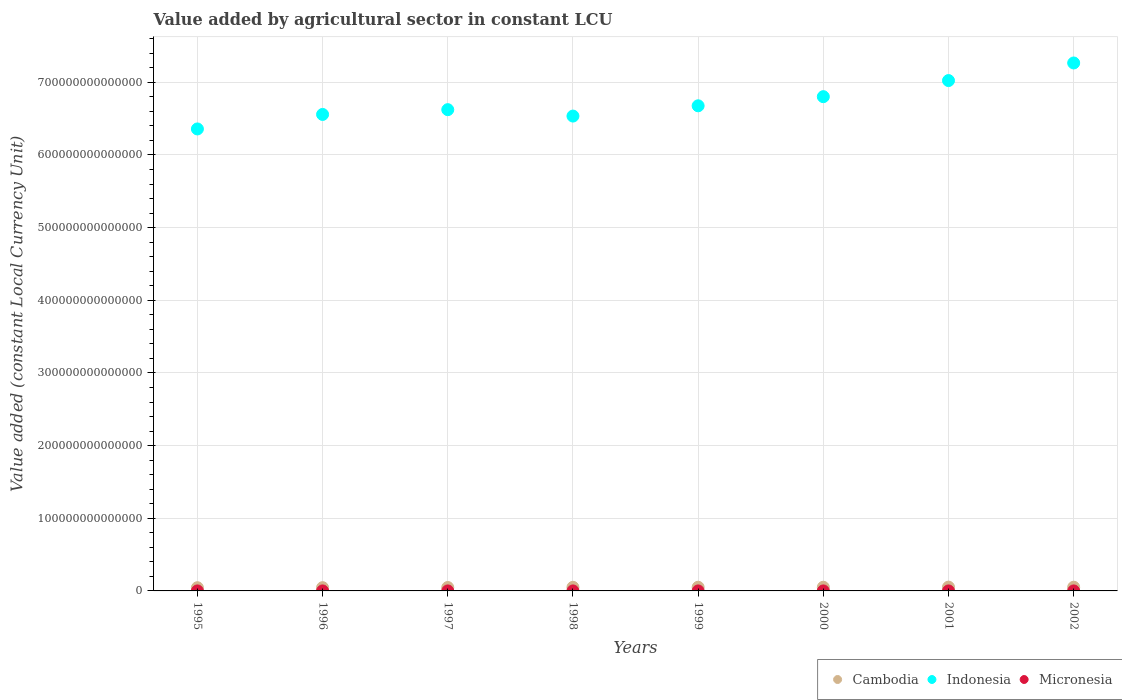How many different coloured dotlines are there?
Your answer should be very brief. 3. What is the value added by agricultural sector in Indonesia in 1995?
Offer a terse response. 6.36e+14. Across all years, what is the maximum value added by agricultural sector in Indonesia?
Your response must be concise. 7.27e+14. Across all years, what is the minimum value added by agricultural sector in Cambodia?
Offer a terse response. 4.42e+12. What is the total value added by agricultural sector in Micronesia in the graph?
Offer a terse response. 4.39e+08. What is the difference between the value added by agricultural sector in Cambodia in 1996 and that in 2000?
Your answer should be compact. -5.79e+11. What is the difference between the value added by agricultural sector in Indonesia in 1995 and the value added by agricultural sector in Cambodia in 2001?
Provide a succinct answer. 6.31e+14. What is the average value added by agricultural sector in Cambodia per year?
Your response must be concise. 4.88e+12. In the year 1998, what is the difference between the value added by agricultural sector in Cambodia and value added by agricultural sector in Indonesia?
Your answer should be very brief. -6.49e+14. In how many years, is the value added by agricultural sector in Cambodia greater than 80000000000000 LCU?
Give a very brief answer. 0. What is the ratio of the value added by agricultural sector in Indonesia in 1997 to that in 2001?
Make the answer very short. 0.94. Is the value added by agricultural sector in Micronesia in 1997 less than that in 2000?
Offer a terse response. Yes. What is the difference between the highest and the second highest value added by agricultural sector in Micronesia?
Ensure brevity in your answer.  5.61e+05. What is the difference between the highest and the lowest value added by agricultural sector in Micronesia?
Give a very brief answer. 7.32e+06. In how many years, is the value added by agricultural sector in Micronesia greater than the average value added by agricultural sector in Micronesia taken over all years?
Make the answer very short. 4. Is the sum of the value added by agricultural sector in Micronesia in 1996 and 1999 greater than the maximum value added by agricultural sector in Indonesia across all years?
Your response must be concise. No. Is it the case that in every year, the sum of the value added by agricultural sector in Indonesia and value added by agricultural sector in Cambodia  is greater than the value added by agricultural sector in Micronesia?
Your response must be concise. Yes. Is the value added by agricultural sector in Indonesia strictly less than the value added by agricultural sector in Micronesia over the years?
Your answer should be compact. No. How many dotlines are there?
Make the answer very short. 3. How many years are there in the graph?
Your response must be concise. 8. What is the difference between two consecutive major ticks on the Y-axis?
Your answer should be very brief. 1.00e+14. Are the values on the major ticks of Y-axis written in scientific E-notation?
Your response must be concise. No. Does the graph contain grids?
Make the answer very short. Yes. How are the legend labels stacked?
Offer a very short reply. Horizontal. What is the title of the graph?
Provide a succinct answer. Value added by agricultural sector in constant LCU. What is the label or title of the X-axis?
Offer a very short reply. Years. What is the label or title of the Y-axis?
Your response must be concise. Value added (constant Local Currency Unit). What is the Value added (constant Local Currency Unit) in Cambodia in 1995?
Provide a succinct answer. 4.42e+12. What is the Value added (constant Local Currency Unit) of Indonesia in 1995?
Ensure brevity in your answer.  6.36e+14. What is the Value added (constant Local Currency Unit) in Micronesia in 1995?
Provide a short and direct response. 5.68e+07. What is the Value added (constant Local Currency Unit) of Cambodia in 1996?
Your response must be concise. 4.48e+12. What is the Value added (constant Local Currency Unit) of Indonesia in 1996?
Provide a succinct answer. 6.56e+14. What is the Value added (constant Local Currency Unit) in Micronesia in 1996?
Provide a succinct answer. 5.46e+07. What is the Value added (constant Local Currency Unit) in Cambodia in 1997?
Your answer should be very brief. 4.72e+12. What is the Value added (constant Local Currency Unit) in Indonesia in 1997?
Ensure brevity in your answer.  6.62e+14. What is the Value added (constant Local Currency Unit) of Micronesia in 1997?
Your answer should be very brief. 5.00e+07. What is the Value added (constant Local Currency Unit) of Cambodia in 1998?
Offer a very short reply. 4.97e+12. What is the Value added (constant Local Currency Unit) in Indonesia in 1998?
Offer a very short reply. 6.54e+14. What is the Value added (constant Local Currency Unit) in Micronesia in 1998?
Ensure brevity in your answer.  5.73e+07. What is the Value added (constant Local Currency Unit) in Cambodia in 1999?
Ensure brevity in your answer.  5.08e+12. What is the Value added (constant Local Currency Unit) of Indonesia in 1999?
Make the answer very short. 6.68e+14. What is the Value added (constant Local Currency Unit) of Micronesia in 1999?
Offer a terse response. 5.30e+07. What is the Value added (constant Local Currency Unit) of Cambodia in 2000?
Offer a very short reply. 5.06e+12. What is the Value added (constant Local Currency Unit) in Indonesia in 2000?
Provide a short and direct response. 6.80e+14. What is the Value added (constant Local Currency Unit) of Micronesia in 2000?
Keep it short and to the point. 5.66e+07. What is the Value added (constant Local Currency Unit) in Cambodia in 2001?
Offer a terse response. 5.24e+12. What is the Value added (constant Local Currency Unit) in Indonesia in 2001?
Give a very brief answer. 7.02e+14. What is the Value added (constant Local Currency Unit) of Micronesia in 2001?
Offer a very short reply. 5.47e+07. What is the Value added (constant Local Currency Unit) of Cambodia in 2002?
Make the answer very short. 5.11e+12. What is the Value added (constant Local Currency Unit) of Indonesia in 2002?
Offer a very short reply. 7.27e+14. What is the Value added (constant Local Currency Unit) in Micronesia in 2002?
Provide a short and direct response. 5.57e+07. Across all years, what is the maximum Value added (constant Local Currency Unit) of Cambodia?
Offer a terse response. 5.24e+12. Across all years, what is the maximum Value added (constant Local Currency Unit) of Indonesia?
Your answer should be compact. 7.27e+14. Across all years, what is the maximum Value added (constant Local Currency Unit) of Micronesia?
Your response must be concise. 5.73e+07. Across all years, what is the minimum Value added (constant Local Currency Unit) of Cambodia?
Provide a succinct answer. 4.42e+12. Across all years, what is the minimum Value added (constant Local Currency Unit) of Indonesia?
Keep it short and to the point. 6.36e+14. Across all years, what is the minimum Value added (constant Local Currency Unit) of Micronesia?
Provide a short and direct response. 5.00e+07. What is the total Value added (constant Local Currency Unit) in Cambodia in the graph?
Keep it short and to the point. 3.91e+13. What is the total Value added (constant Local Currency Unit) in Indonesia in the graph?
Ensure brevity in your answer.  5.38e+15. What is the total Value added (constant Local Currency Unit) in Micronesia in the graph?
Ensure brevity in your answer.  4.39e+08. What is the difference between the Value added (constant Local Currency Unit) of Cambodia in 1995 and that in 1996?
Ensure brevity in your answer.  -5.79e+1. What is the difference between the Value added (constant Local Currency Unit) in Indonesia in 1995 and that in 1996?
Your response must be concise. -2.00e+13. What is the difference between the Value added (constant Local Currency Unit) in Micronesia in 1995 and that in 1996?
Offer a terse response. 2.14e+06. What is the difference between the Value added (constant Local Currency Unit) in Cambodia in 1995 and that in 1997?
Keep it short and to the point. -3.01e+11. What is the difference between the Value added (constant Local Currency Unit) of Indonesia in 1995 and that in 1997?
Provide a succinct answer. -2.65e+13. What is the difference between the Value added (constant Local Currency Unit) of Micronesia in 1995 and that in 1997?
Keep it short and to the point. 6.76e+06. What is the difference between the Value added (constant Local Currency Unit) of Cambodia in 1995 and that in 1998?
Your response must be concise. -5.45e+11. What is the difference between the Value added (constant Local Currency Unit) in Indonesia in 1995 and that in 1998?
Provide a short and direct response. -1.77e+13. What is the difference between the Value added (constant Local Currency Unit) of Micronesia in 1995 and that in 1998?
Your answer should be very brief. -5.61e+05. What is the difference between the Value added (constant Local Currency Unit) in Cambodia in 1995 and that in 1999?
Your answer should be compact. -6.56e+11. What is the difference between the Value added (constant Local Currency Unit) in Indonesia in 1995 and that in 1999?
Provide a short and direct response. -3.19e+13. What is the difference between the Value added (constant Local Currency Unit) in Micronesia in 1995 and that in 1999?
Offer a very short reply. 3.80e+06. What is the difference between the Value added (constant Local Currency Unit) in Cambodia in 1995 and that in 2000?
Your response must be concise. -6.37e+11. What is the difference between the Value added (constant Local Currency Unit) of Indonesia in 1995 and that in 2000?
Give a very brief answer. -4.44e+13. What is the difference between the Value added (constant Local Currency Unit) in Micronesia in 1995 and that in 2000?
Your answer should be very brief. 2.23e+05. What is the difference between the Value added (constant Local Currency Unit) of Cambodia in 1995 and that in 2001?
Keep it short and to the point. -8.17e+11. What is the difference between the Value added (constant Local Currency Unit) of Indonesia in 1995 and that in 2001?
Ensure brevity in your answer.  -6.66e+13. What is the difference between the Value added (constant Local Currency Unit) in Micronesia in 1995 and that in 2001?
Provide a short and direct response. 2.12e+06. What is the difference between the Value added (constant Local Currency Unit) of Cambodia in 1995 and that in 2002?
Make the answer very short. -6.86e+11. What is the difference between the Value added (constant Local Currency Unit) in Indonesia in 1995 and that in 2002?
Provide a succinct answer. -9.08e+13. What is the difference between the Value added (constant Local Currency Unit) in Micronesia in 1995 and that in 2002?
Your answer should be very brief. 1.03e+06. What is the difference between the Value added (constant Local Currency Unit) in Cambodia in 1996 and that in 1997?
Ensure brevity in your answer.  -2.43e+11. What is the difference between the Value added (constant Local Currency Unit) in Indonesia in 1996 and that in 1997?
Offer a terse response. -6.58e+12. What is the difference between the Value added (constant Local Currency Unit) of Micronesia in 1996 and that in 1997?
Your answer should be compact. 4.62e+06. What is the difference between the Value added (constant Local Currency Unit) in Cambodia in 1996 and that in 1998?
Offer a very short reply. -4.87e+11. What is the difference between the Value added (constant Local Currency Unit) of Indonesia in 1996 and that in 1998?
Give a very brief answer. 2.24e+12. What is the difference between the Value added (constant Local Currency Unit) in Micronesia in 1996 and that in 1998?
Provide a short and direct response. -2.70e+06. What is the difference between the Value added (constant Local Currency Unit) of Cambodia in 1996 and that in 1999?
Provide a short and direct response. -5.98e+11. What is the difference between the Value added (constant Local Currency Unit) in Indonesia in 1996 and that in 1999?
Offer a terse response. -1.19e+13. What is the difference between the Value added (constant Local Currency Unit) in Micronesia in 1996 and that in 1999?
Ensure brevity in your answer.  1.66e+06. What is the difference between the Value added (constant Local Currency Unit) of Cambodia in 1996 and that in 2000?
Your response must be concise. -5.79e+11. What is the difference between the Value added (constant Local Currency Unit) in Indonesia in 1996 and that in 2000?
Your answer should be very brief. -2.45e+13. What is the difference between the Value added (constant Local Currency Unit) in Micronesia in 1996 and that in 2000?
Offer a terse response. -1.92e+06. What is the difference between the Value added (constant Local Currency Unit) in Cambodia in 1996 and that in 2001?
Give a very brief answer. -7.59e+11. What is the difference between the Value added (constant Local Currency Unit) of Indonesia in 1996 and that in 2001?
Your response must be concise. -4.66e+13. What is the difference between the Value added (constant Local Currency Unit) of Micronesia in 1996 and that in 2001?
Give a very brief answer. -1.49e+04. What is the difference between the Value added (constant Local Currency Unit) of Cambodia in 1996 and that in 2002?
Give a very brief answer. -6.29e+11. What is the difference between the Value added (constant Local Currency Unit) in Indonesia in 1996 and that in 2002?
Offer a very short reply. -7.08e+13. What is the difference between the Value added (constant Local Currency Unit) of Micronesia in 1996 and that in 2002?
Provide a succinct answer. -1.11e+06. What is the difference between the Value added (constant Local Currency Unit) in Cambodia in 1997 and that in 1998?
Offer a terse response. -2.45e+11. What is the difference between the Value added (constant Local Currency Unit) in Indonesia in 1997 and that in 1998?
Provide a succinct answer. 8.82e+12. What is the difference between the Value added (constant Local Currency Unit) in Micronesia in 1997 and that in 1998?
Provide a succinct answer. -7.32e+06. What is the difference between the Value added (constant Local Currency Unit) in Cambodia in 1997 and that in 1999?
Provide a succinct answer. -3.56e+11. What is the difference between the Value added (constant Local Currency Unit) in Indonesia in 1997 and that in 1999?
Your response must be concise. -5.32e+12. What is the difference between the Value added (constant Local Currency Unit) of Micronesia in 1997 and that in 1999?
Offer a terse response. -2.96e+06. What is the difference between the Value added (constant Local Currency Unit) of Cambodia in 1997 and that in 2000?
Ensure brevity in your answer.  -3.36e+11. What is the difference between the Value added (constant Local Currency Unit) in Indonesia in 1997 and that in 2000?
Offer a terse response. -1.79e+13. What is the difference between the Value added (constant Local Currency Unit) of Micronesia in 1997 and that in 2000?
Your response must be concise. -6.54e+06. What is the difference between the Value added (constant Local Currency Unit) of Cambodia in 1997 and that in 2001?
Your response must be concise. -5.16e+11. What is the difference between the Value added (constant Local Currency Unit) of Indonesia in 1997 and that in 2001?
Your answer should be compact. -4.00e+13. What is the difference between the Value added (constant Local Currency Unit) in Micronesia in 1997 and that in 2001?
Your answer should be compact. -4.64e+06. What is the difference between the Value added (constant Local Currency Unit) in Cambodia in 1997 and that in 2002?
Give a very brief answer. -3.86e+11. What is the difference between the Value added (constant Local Currency Unit) of Indonesia in 1997 and that in 2002?
Offer a terse response. -6.43e+13. What is the difference between the Value added (constant Local Currency Unit) of Micronesia in 1997 and that in 2002?
Offer a very short reply. -5.73e+06. What is the difference between the Value added (constant Local Currency Unit) of Cambodia in 1998 and that in 1999?
Your answer should be compact. -1.11e+11. What is the difference between the Value added (constant Local Currency Unit) in Indonesia in 1998 and that in 1999?
Give a very brief answer. -1.41e+13. What is the difference between the Value added (constant Local Currency Unit) in Micronesia in 1998 and that in 1999?
Give a very brief answer. 4.36e+06. What is the difference between the Value added (constant Local Currency Unit) in Cambodia in 1998 and that in 2000?
Give a very brief answer. -9.16e+1. What is the difference between the Value added (constant Local Currency Unit) of Indonesia in 1998 and that in 2000?
Your answer should be compact. -2.67e+13. What is the difference between the Value added (constant Local Currency Unit) in Micronesia in 1998 and that in 2000?
Give a very brief answer. 7.85e+05. What is the difference between the Value added (constant Local Currency Unit) in Cambodia in 1998 and that in 2001?
Your response must be concise. -2.72e+11. What is the difference between the Value added (constant Local Currency Unit) of Indonesia in 1998 and that in 2001?
Offer a very short reply. -4.89e+13. What is the difference between the Value added (constant Local Currency Unit) in Micronesia in 1998 and that in 2001?
Give a very brief answer. 2.69e+06. What is the difference between the Value added (constant Local Currency Unit) of Cambodia in 1998 and that in 2002?
Your answer should be very brief. -1.41e+11. What is the difference between the Value added (constant Local Currency Unit) of Indonesia in 1998 and that in 2002?
Offer a very short reply. -7.31e+13. What is the difference between the Value added (constant Local Currency Unit) in Micronesia in 1998 and that in 2002?
Your response must be concise. 1.59e+06. What is the difference between the Value added (constant Local Currency Unit) of Cambodia in 1999 and that in 2000?
Your answer should be very brief. 1.93e+1. What is the difference between the Value added (constant Local Currency Unit) in Indonesia in 1999 and that in 2000?
Make the answer very short. -1.26e+13. What is the difference between the Value added (constant Local Currency Unit) in Micronesia in 1999 and that in 2000?
Make the answer very short. -3.58e+06. What is the difference between the Value added (constant Local Currency Unit) of Cambodia in 1999 and that in 2001?
Your answer should be compact. -1.61e+11. What is the difference between the Value added (constant Local Currency Unit) in Indonesia in 1999 and that in 2001?
Provide a short and direct response. -3.47e+13. What is the difference between the Value added (constant Local Currency Unit) of Micronesia in 1999 and that in 2001?
Provide a short and direct response. -1.68e+06. What is the difference between the Value added (constant Local Currency Unit) in Cambodia in 1999 and that in 2002?
Provide a succinct answer. -3.04e+1. What is the difference between the Value added (constant Local Currency Unit) in Indonesia in 1999 and that in 2002?
Your answer should be very brief. -5.89e+13. What is the difference between the Value added (constant Local Currency Unit) in Micronesia in 1999 and that in 2002?
Your response must be concise. -2.77e+06. What is the difference between the Value added (constant Local Currency Unit) in Cambodia in 2000 and that in 2001?
Your answer should be compact. -1.80e+11. What is the difference between the Value added (constant Local Currency Unit) of Indonesia in 2000 and that in 2001?
Offer a very short reply. -2.21e+13. What is the difference between the Value added (constant Local Currency Unit) in Micronesia in 2000 and that in 2001?
Make the answer very short. 1.90e+06. What is the difference between the Value added (constant Local Currency Unit) in Cambodia in 2000 and that in 2002?
Your answer should be very brief. -4.97e+1. What is the difference between the Value added (constant Local Currency Unit) of Indonesia in 2000 and that in 2002?
Ensure brevity in your answer.  -4.64e+13. What is the difference between the Value added (constant Local Currency Unit) in Micronesia in 2000 and that in 2002?
Provide a succinct answer. 8.08e+05. What is the difference between the Value added (constant Local Currency Unit) of Cambodia in 2001 and that in 2002?
Your response must be concise. 1.30e+11. What is the difference between the Value added (constant Local Currency Unit) of Indonesia in 2001 and that in 2002?
Keep it short and to the point. -2.42e+13. What is the difference between the Value added (constant Local Currency Unit) of Micronesia in 2001 and that in 2002?
Offer a terse response. -1.09e+06. What is the difference between the Value added (constant Local Currency Unit) of Cambodia in 1995 and the Value added (constant Local Currency Unit) of Indonesia in 1996?
Provide a short and direct response. -6.51e+14. What is the difference between the Value added (constant Local Currency Unit) of Cambodia in 1995 and the Value added (constant Local Currency Unit) of Micronesia in 1996?
Provide a short and direct response. 4.42e+12. What is the difference between the Value added (constant Local Currency Unit) in Indonesia in 1995 and the Value added (constant Local Currency Unit) in Micronesia in 1996?
Offer a very short reply. 6.36e+14. What is the difference between the Value added (constant Local Currency Unit) in Cambodia in 1995 and the Value added (constant Local Currency Unit) in Indonesia in 1997?
Your answer should be compact. -6.58e+14. What is the difference between the Value added (constant Local Currency Unit) of Cambodia in 1995 and the Value added (constant Local Currency Unit) of Micronesia in 1997?
Keep it short and to the point. 4.42e+12. What is the difference between the Value added (constant Local Currency Unit) in Indonesia in 1995 and the Value added (constant Local Currency Unit) in Micronesia in 1997?
Make the answer very short. 6.36e+14. What is the difference between the Value added (constant Local Currency Unit) in Cambodia in 1995 and the Value added (constant Local Currency Unit) in Indonesia in 1998?
Provide a succinct answer. -6.49e+14. What is the difference between the Value added (constant Local Currency Unit) in Cambodia in 1995 and the Value added (constant Local Currency Unit) in Micronesia in 1998?
Offer a very short reply. 4.42e+12. What is the difference between the Value added (constant Local Currency Unit) in Indonesia in 1995 and the Value added (constant Local Currency Unit) in Micronesia in 1998?
Give a very brief answer. 6.36e+14. What is the difference between the Value added (constant Local Currency Unit) in Cambodia in 1995 and the Value added (constant Local Currency Unit) in Indonesia in 1999?
Your response must be concise. -6.63e+14. What is the difference between the Value added (constant Local Currency Unit) of Cambodia in 1995 and the Value added (constant Local Currency Unit) of Micronesia in 1999?
Keep it short and to the point. 4.42e+12. What is the difference between the Value added (constant Local Currency Unit) of Indonesia in 1995 and the Value added (constant Local Currency Unit) of Micronesia in 1999?
Offer a very short reply. 6.36e+14. What is the difference between the Value added (constant Local Currency Unit) of Cambodia in 1995 and the Value added (constant Local Currency Unit) of Indonesia in 2000?
Provide a short and direct response. -6.76e+14. What is the difference between the Value added (constant Local Currency Unit) in Cambodia in 1995 and the Value added (constant Local Currency Unit) in Micronesia in 2000?
Provide a short and direct response. 4.42e+12. What is the difference between the Value added (constant Local Currency Unit) in Indonesia in 1995 and the Value added (constant Local Currency Unit) in Micronesia in 2000?
Give a very brief answer. 6.36e+14. What is the difference between the Value added (constant Local Currency Unit) in Cambodia in 1995 and the Value added (constant Local Currency Unit) in Indonesia in 2001?
Give a very brief answer. -6.98e+14. What is the difference between the Value added (constant Local Currency Unit) of Cambodia in 1995 and the Value added (constant Local Currency Unit) of Micronesia in 2001?
Offer a very short reply. 4.42e+12. What is the difference between the Value added (constant Local Currency Unit) of Indonesia in 1995 and the Value added (constant Local Currency Unit) of Micronesia in 2001?
Your answer should be compact. 6.36e+14. What is the difference between the Value added (constant Local Currency Unit) of Cambodia in 1995 and the Value added (constant Local Currency Unit) of Indonesia in 2002?
Give a very brief answer. -7.22e+14. What is the difference between the Value added (constant Local Currency Unit) of Cambodia in 1995 and the Value added (constant Local Currency Unit) of Micronesia in 2002?
Your answer should be compact. 4.42e+12. What is the difference between the Value added (constant Local Currency Unit) in Indonesia in 1995 and the Value added (constant Local Currency Unit) in Micronesia in 2002?
Offer a very short reply. 6.36e+14. What is the difference between the Value added (constant Local Currency Unit) in Cambodia in 1996 and the Value added (constant Local Currency Unit) in Indonesia in 1997?
Your answer should be very brief. -6.58e+14. What is the difference between the Value added (constant Local Currency Unit) in Cambodia in 1996 and the Value added (constant Local Currency Unit) in Micronesia in 1997?
Make the answer very short. 4.48e+12. What is the difference between the Value added (constant Local Currency Unit) of Indonesia in 1996 and the Value added (constant Local Currency Unit) of Micronesia in 1997?
Make the answer very short. 6.56e+14. What is the difference between the Value added (constant Local Currency Unit) of Cambodia in 1996 and the Value added (constant Local Currency Unit) of Indonesia in 1998?
Provide a succinct answer. -6.49e+14. What is the difference between the Value added (constant Local Currency Unit) of Cambodia in 1996 and the Value added (constant Local Currency Unit) of Micronesia in 1998?
Your response must be concise. 4.48e+12. What is the difference between the Value added (constant Local Currency Unit) in Indonesia in 1996 and the Value added (constant Local Currency Unit) in Micronesia in 1998?
Offer a very short reply. 6.56e+14. What is the difference between the Value added (constant Local Currency Unit) in Cambodia in 1996 and the Value added (constant Local Currency Unit) in Indonesia in 1999?
Keep it short and to the point. -6.63e+14. What is the difference between the Value added (constant Local Currency Unit) in Cambodia in 1996 and the Value added (constant Local Currency Unit) in Micronesia in 1999?
Keep it short and to the point. 4.48e+12. What is the difference between the Value added (constant Local Currency Unit) of Indonesia in 1996 and the Value added (constant Local Currency Unit) of Micronesia in 1999?
Give a very brief answer. 6.56e+14. What is the difference between the Value added (constant Local Currency Unit) of Cambodia in 1996 and the Value added (constant Local Currency Unit) of Indonesia in 2000?
Give a very brief answer. -6.76e+14. What is the difference between the Value added (constant Local Currency Unit) of Cambodia in 1996 and the Value added (constant Local Currency Unit) of Micronesia in 2000?
Ensure brevity in your answer.  4.48e+12. What is the difference between the Value added (constant Local Currency Unit) in Indonesia in 1996 and the Value added (constant Local Currency Unit) in Micronesia in 2000?
Give a very brief answer. 6.56e+14. What is the difference between the Value added (constant Local Currency Unit) of Cambodia in 1996 and the Value added (constant Local Currency Unit) of Indonesia in 2001?
Provide a succinct answer. -6.98e+14. What is the difference between the Value added (constant Local Currency Unit) of Cambodia in 1996 and the Value added (constant Local Currency Unit) of Micronesia in 2001?
Provide a short and direct response. 4.48e+12. What is the difference between the Value added (constant Local Currency Unit) in Indonesia in 1996 and the Value added (constant Local Currency Unit) in Micronesia in 2001?
Give a very brief answer. 6.56e+14. What is the difference between the Value added (constant Local Currency Unit) in Cambodia in 1996 and the Value added (constant Local Currency Unit) in Indonesia in 2002?
Give a very brief answer. -7.22e+14. What is the difference between the Value added (constant Local Currency Unit) in Cambodia in 1996 and the Value added (constant Local Currency Unit) in Micronesia in 2002?
Your answer should be very brief. 4.48e+12. What is the difference between the Value added (constant Local Currency Unit) in Indonesia in 1996 and the Value added (constant Local Currency Unit) in Micronesia in 2002?
Give a very brief answer. 6.56e+14. What is the difference between the Value added (constant Local Currency Unit) of Cambodia in 1997 and the Value added (constant Local Currency Unit) of Indonesia in 1998?
Keep it short and to the point. -6.49e+14. What is the difference between the Value added (constant Local Currency Unit) of Cambodia in 1997 and the Value added (constant Local Currency Unit) of Micronesia in 1998?
Offer a terse response. 4.72e+12. What is the difference between the Value added (constant Local Currency Unit) in Indonesia in 1997 and the Value added (constant Local Currency Unit) in Micronesia in 1998?
Your answer should be compact. 6.62e+14. What is the difference between the Value added (constant Local Currency Unit) of Cambodia in 1997 and the Value added (constant Local Currency Unit) of Indonesia in 1999?
Offer a very short reply. -6.63e+14. What is the difference between the Value added (constant Local Currency Unit) in Cambodia in 1997 and the Value added (constant Local Currency Unit) in Micronesia in 1999?
Offer a terse response. 4.72e+12. What is the difference between the Value added (constant Local Currency Unit) of Indonesia in 1997 and the Value added (constant Local Currency Unit) of Micronesia in 1999?
Your answer should be very brief. 6.62e+14. What is the difference between the Value added (constant Local Currency Unit) of Cambodia in 1997 and the Value added (constant Local Currency Unit) of Indonesia in 2000?
Your answer should be very brief. -6.76e+14. What is the difference between the Value added (constant Local Currency Unit) in Cambodia in 1997 and the Value added (constant Local Currency Unit) in Micronesia in 2000?
Provide a short and direct response. 4.72e+12. What is the difference between the Value added (constant Local Currency Unit) of Indonesia in 1997 and the Value added (constant Local Currency Unit) of Micronesia in 2000?
Offer a very short reply. 6.62e+14. What is the difference between the Value added (constant Local Currency Unit) of Cambodia in 1997 and the Value added (constant Local Currency Unit) of Indonesia in 2001?
Ensure brevity in your answer.  -6.98e+14. What is the difference between the Value added (constant Local Currency Unit) in Cambodia in 1997 and the Value added (constant Local Currency Unit) in Micronesia in 2001?
Your response must be concise. 4.72e+12. What is the difference between the Value added (constant Local Currency Unit) of Indonesia in 1997 and the Value added (constant Local Currency Unit) of Micronesia in 2001?
Your answer should be compact. 6.62e+14. What is the difference between the Value added (constant Local Currency Unit) in Cambodia in 1997 and the Value added (constant Local Currency Unit) in Indonesia in 2002?
Ensure brevity in your answer.  -7.22e+14. What is the difference between the Value added (constant Local Currency Unit) in Cambodia in 1997 and the Value added (constant Local Currency Unit) in Micronesia in 2002?
Offer a terse response. 4.72e+12. What is the difference between the Value added (constant Local Currency Unit) in Indonesia in 1997 and the Value added (constant Local Currency Unit) in Micronesia in 2002?
Your answer should be compact. 6.62e+14. What is the difference between the Value added (constant Local Currency Unit) in Cambodia in 1998 and the Value added (constant Local Currency Unit) in Indonesia in 1999?
Provide a short and direct response. -6.63e+14. What is the difference between the Value added (constant Local Currency Unit) of Cambodia in 1998 and the Value added (constant Local Currency Unit) of Micronesia in 1999?
Provide a short and direct response. 4.97e+12. What is the difference between the Value added (constant Local Currency Unit) in Indonesia in 1998 and the Value added (constant Local Currency Unit) in Micronesia in 1999?
Give a very brief answer. 6.54e+14. What is the difference between the Value added (constant Local Currency Unit) of Cambodia in 1998 and the Value added (constant Local Currency Unit) of Indonesia in 2000?
Offer a terse response. -6.75e+14. What is the difference between the Value added (constant Local Currency Unit) of Cambodia in 1998 and the Value added (constant Local Currency Unit) of Micronesia in 2000?
Provide a short and direct response. 4.97e+12. What is the difference between the Value added (constant Local Currency Unit) in Indonesia in 1998 and the Value added (constant Local Currency Unit) in Micronesia in 2000?
Your answer should be very brief. 6.54e+14. What is the difference between the Value added (constant Local Currency Unit) in Cambodia in 1998 and the Value added (constant Local Currency Unit) in Indonesia in 2001?
Make the answer very short. -6.97e+14. What is the difference between the Value added (constant Local Currency Unit) of Cambodia in 1998 and the Value added (constant Local Currency Unit) of Micronesia in 2001?
Your response must be concise. 4.97e+12. What is the difference between the Value added (constant Local Currency Unit) of Indonesia in 1998 and the Value added (constant Local Currency Unit) of Micronesia in 2001?
Your answer should be very brief. 6.54e+14. What is the difference between the Value added (constant Local Currency Unit) of Cambodia in 1998 and the Value added (constant Local Currency Unit) of Indonesia in 2002?
Your answer should be compact. -7.22e+14. What is the difference between the Value added (constant Local Currency Unit) in Cambodia in 1998 and the Value added (constant Local Currency Unit) in Micronesia in 2002?
Make the answer very short. 4.97e+12. What is the difference between the Value added (constant Local Currency Unit) of Indonesia in 1998 and the Value added (constant Local Currency Unit) of Micronesia in 2002?
Provide a short and direct response. 6.54e+14. What is the difference between the Value added (constant Local Currency Unit) in Cambodia in 1999 and the Value added (constant Local Currency Unit) in Indonesia in 2000?
Ensure brevity in your answer.  -6.75e+14. What is the difference between the Value added (constant Local Currency Unit) of Cambodia in 1999 and the Value added (constant Local Currency Unit) of Micronesia in 2000?
Your response must be concise. 5.08e+12. What is the difference between the Value added (constant Local Currency Unit) in Indonesia in 1999 and the Value added (constant Local Currency Unit) in Micronesia in 2000?
Provide a succinct answer. 6.68e+14. What is the difference between the Value added (constant Local Currency Unit) in Cambodia in 1999 and the Value added (constant Local Currency Unit) in Indonesia in 2001?
Your response must be concise. -6.97e+14. What is the difference between the Value added (constant Local Currency Unit) in Cambodia in 1999 and the Value added (constant Local Currency Unit) in Micronesia in 2001?
Offer a very short reply. 5.08e+12. What is the difference between the Value added (constant Local Currency Unit) of Indonesia in 1999 and the Value added (constant Local Currency Unit) of Micronesia in 2001?
Make the answer very short. 6.68e+14. What is the difference between the Value added (constant Local Currency Unit) in Cambodia in 1999 and the Value added (constant Local Currency Unit) in Indonesia in 2002?
Ensure brevity in your answer.  -7.22e+14. What is the difference between the Value added (constant Local Currency Unit) of Cambodia in 1999 and the Value added (constant Local Currency Unit) of Micronesia in 2002?
Provide a short and direct response. 5.08e+12. What is the difference between the Value added (constant Local Currency Unit) of Indonesia in 1999 and the Value added (constant Local Currency Unit) of Micronesia in 2002?
Your response must be concise. 6.68e+14. What is the difference between the Value added (constant Local Currency Unit) of Cambodia in 2000 and the Value added (constant Local Currency Unit) of Indonesia in 2001?
Offer a very short reply. -6.97e+14. What is the difference between the Value added (constant Local Currency Unit) in Cambodia in 2000 and the Value added (constant Local Currency Unit) in Micronesia in 2001?
Provide a short and direct response. 5.06e+12. What is the difference between the Value added (constant Local Currency Unit) of Indonesia in 2000 and the Value added (constant Local Currency Unit) of Micronesia in 2001?
Provide a short and direct response. 6.80e+14. What is the difference between the Value added (constant Local Currency Unit) in Cambodia in 2000 and the Value added (constant Local Currency Unit) in Indonesia in 2002?
Your answer should be very brief. -7.22e+14. What is the difference between the Value added (constant Local Currency Unit) in Cambodia in 2000 and the Value added (constant Local Currency Unit) in Micronesia in 2002?
Keep it short and to the point. 5.06e+12. What is the difference between the Value added (constant Local Currency Unit) in Indonesia in 2000 and the Value added (constant Local Currency Unit) in Micronesia in 2002?
Offer a terse response. 6.80e+14. What is the difference between the Value added (constant Local Currency Unit) in Cambodia in 2001 and the Value added (constant Local Currency Unit) in Indonesia in 2002?
Offer a terse response. -7.21e+14. What is the difference between the Value added (constant Local Currency Unit) of Cambodia in 2001 and the Value added (constant Local Currency Unit) of Micronesia in 2002?
Your answer should be very brief. 5.24e+12. What is the difference between the Value added (constant Local Currency Unit) of Indonesia in 2001 and the Value added (constant Local Currency Unit) of Micronesia in 2002?
Make the answer very short. 7.02e+14. What is the average Value added (constant Local Currency Unit) in Cambodia per year?
Offer a terse response. 4.88e+12. What is the average Value added (constant Local Currency Unit) in Indonesia per year?
Offer a terse response. 6.73e+14. What is the average Value added (constant Local Currency Unit) in Micronesia per year?
Provide a succinct answer. 5.48e+07. In the year 1995, what is the difference between the Value added (constant Local Currency Unit) of Cambodia and Value added (constant Local Currency Unit) of Indonesia?
Your answer should be very brief. -6.31e+14. In the year 1995, what is the difference between the Value added (constant Local Currency Unit) of Cambodia and Value added (constant Local Currency Unit) of Micronesia?
Your answer should be very brief. 4.42e+12. In the year 1995, what is the difference between the Value added (constant Local Currency Unit) in Indonesia and Value added (constant Local Currency Unit) in Micronesia?
Your answer should be compact. 6.36e+14. In the year 1996, what is the difference between the Value added (constant Local Currency Unit) of Cambodia and Value added (constant Local Currency Unit) of Indonesia?
Offer a very short reply. -6.51e+14. In the year 1996, what is the difference between the Value added (constant Local Currency Unit) of Cambodia and Value added (constant Local Currency Unit) of Micronesia?
Keep it short and to the point. 4.48e+12. In the year 1996, what is the difference between the Value added (constant Local Currency Unit) of Indonesia and Value added (constant Local Currency Unit) of Micronesia?
Offer a very short reply. 6.56e+14. In the year 1997, what is the difference between the Value added (constant Local Currency Unit) in Cambodia and Value added (constant Local Currency Unit) in Indonesia?
Provide a short and direct response. -6.58e+14. In the year 1997, what is the difference between the Value added (constant Local Currency Unit) of Cambodia and Value added (constant Local Currency Unit) of Micronesia?
Make the answer very short. 4.72e+12. In the year 1997, what is the difference between the Value added (constant Local Currency Unit) in Indonesia and Value added (constant Local Currency Unit) in Micronesia?
Make the answer very short. 6.62e+14. In the year 1998, what is the difference between the Value added (constant Local Currency Unit) of Cambodia and Value added (constant Local Currency Unit) of Indonesia?
Your answer should be compact. -6.49e+14. In the year 1998, what is the difference between the Value added (constant Local Currency Unit) of Cambodia and Value added (constant Local Currency Unit) of Micronesia?
Your response must be concise. 4.97e+12. In the year 1998, what is the difference between the Value added (constant Local Currency Unit) in Indonesia and Value added (constant Local Currency Unit) in Micronesia?
Make the answer very short. 6.54e+14. In the year 1999, what is the difference between the Value added (constant Local Currency Unit) in Cambodia and Value added (constant Local Currency Unit) in Indonesia?
Offer a very short reply. -6.63e+14. In the year 1999, what is the difference between the Value added (constant Local Currency Unit) of Cambodia and Value added (constant Local Currency Unit) of Micronesia?
Provide a succinct answer. 5.08e+12. In the year 1999, what is the difference between the Value added (constant Local Currency Unit) in Indonesia and Value added (constant Local Currency Unit) in Micronesia?
Keep it short and to the point. 6.68e+14. In the year 2000, what is the difference between the Value added (constant Local Currency Unit) in Cambodia and Value added (constant Local Currency Unit) in Indonesia?
Offer a terse response. -6.75e+14. In the year 2000, what is the difference between the Value added (constant Local Currency Unit) in Cambodia and Value added (constant Local Currency Unit) in Micronesia?
Keep it short and to the point. 5.06e+12. In the year 2000, what is the difference between the Value added (constant Local Currency Unit) in Indonesia and Value added (constant Local Currency Unit) in Micronesia?
Provide a short and direct response. 6.80e+14. In the year 2001, what is the difference between the Value added (constant Local Currency Unit) of Cambodia and Value added (constant Local Currency Unit) of Indonesia?
Provide a short and direct response. -6.97e+14. In the year 2001, what is the difference between the Value added (constant Local Currency Unit) in Cambodia and Value added (constant Local Currency Unit) in Micronesia?
Your response must be concise. 5.24e+12. In the year 2001, what is the difference between the Value added (constant Local Currency Unit) in Indonesia and Value added (constant Local Currency Unit) in Micronesia?
Your answer should be compact. 7.02e+14. In the year 2002, what is the difference between the Value added (constant Local Currency Unit) in Cambodia and Value added (constant Local Currency Unit) in Indonesia?
Give a very brief answer. -7.21e+14. In the year 2002, what is the difference between the Value added (constant Local Currency Unit) of Cambodia and Value added (constant Local Currency Unit) of Micronesia?
Ensure brevity in your answer.  5.11e+12. In the year 2002, what is the difference between the Value added (constant Local Currency Unit) of Indonesia and Value added (constant Local Currency Unit) of Micronesia?
Offer a very short reply. 7.27e+14. What is the ratio of the Value added (constant Local Currency Unit) of Cambodia in 1995 to that in 1996?
Offer a very short reply. 0.99. What is the ratio of the Value added (constant Local Currency Unit) in Indonesia in 1995 to that in 1996?
Your answer should be compact. 0.97. What is the ratio of the Value added (constant Local Currency Unit) in Micronesia in 1995 to that in 1996?
Your answer should be compact. 1.04. What is the ratio of the Value added (constant Local Currency Unit) of Cambodia in 1995 to that in 1997?
Offer a terse response. 0.94. What is the ratio of the Value added (constant Local Currency Unit) in Indonesia in 1995 to that in 1997?
Your answer should be compact. 0.96. What is the ratio of the Value added (constant Local Currency Unit) of Micronesia in 1995 to that in 1997?
Your answer should be compact. 1.14. What is the ratio of the Value added (constant Local Currency Unit) of Cambodia in 1995 to that in 1998?
Keep it short and to the point. 0.89. What is the ratio of the Value added (constant Local Currency Unit) of Indonesia in 1995 to that in 1998?
Provide a succinct answer. 0.97. What is the ratio of the Value added (constant Local Currency Unit) of Micronesia in 1995 to that in 1998?
Offer a terse response. 0.99. What is the ratio of the Value added (constant Local Currency Unit) of Cambodia in 1995 to that in 1999?
Your response must be concise. 0.87. What is the ratio of the Value added (constant Local Currency Unit) in Indonesia in 1995 to that in 1999?
Offer a very short reply. 0.95. What is the ratio of the Value added (constant Local Currency Unit) in Micronesia in 1995 to that in 1999?
Make the answer very short. 1.07. What is the ratio of the Value added (constant Local Currency Unit) in Cambodia in 1995 to that in 2000?
Give a very brief answer. 0.87. What is the ratio of the Value added (constant Local Currency Unit) of Indonesia in 1995 to that in 2000?
Your answer should be very brief. 0.93. What is the ratio of the Value added (constant Local Currency Unit) of Cambodia in 1995 to that in 2001?
Your answer should be compact. 0.84. What is the ratio of the Value added (constant Local Currency Unit) in Indonesia in 1995 to that in 2001?
Make the answer very short. 0.91. What is the ratio of the Value added (constant Local Currency Unit) in Micronesia in 1995 to that in 2001?
Offer a very short reply. 1.04. What is the ratio of the Value added (constant Local Currency Unit) in Cambodia in 1995 to that in 2002?
Make the answer very short. 0.87. What is the ratio of the Value added (constant Local Currency Unit) of Micronesia in 1995 to that in 2002?
Your answer should be very brief. 1.02. What is the ratio of the Value added (constant Local Currency Unit) of Cambodia in 1996 to that in 1997?
Provide a succinct answer. 0.95. What is the ratio of the Value added (constant Local Currency Unit) of Indonesia in 1996 to that in 1997?
Keep it short and to the point. 0.99. What is the ratio of the Value added (constant Local Currency Unit) in Micronesia in 1996 to that in 1997?
Your answer should be very brief. 1.09. What is the ratio of the Value added (constant Local Currency Unit) of Cambodia in 1996 to that in 1998?
Provide a succinct answer. 0.9. What is the ratio of the Value added (constant Local Currency Unit) of Indonesia in 1996 to that in 1998?
Keep it short and to the point. 1. What is the ratio of the Value added (constant Local Currency Unit) in Micronesia in 1996 to that in 1998?
Make the answer very short. 0.95. What is the ratio of the Value added (constant Local Currency Unit) in Cambodia in 1996 to that in 1999?
Make the answer very short. 0.88. What is the ratio of the Value added (constant Local Currency Unit) in Indonesia in 1996 to that in 1999?
Offer a very short reply. 0.98. What is the ratio of the Value added (constant Local Currency Unit) in Micronesia in 1996 to that in 1999?
Give a very brief answer. 1.03. What is the ratio of the Value added (constant Local Currency Unit) of Cambodia in 1996 to that in 2000?
Give a very brief answer. 0.89. What is the ratio of the Value added (constant Local Currency Unit) in Micronesia in 1996 to that in 2000?
Offer a terse response. 0.97. What is the ratio of the Value added (constant Local Currency Unit) in Cambodia in 1996 to that in 2001?
Ensure brevity in your answer.  0.86. What is the ratio of the Value added (constant Local Currency Unit) in Indonesia in 1996 to that in 2001?
Provide a succinct answer. 0.93. What is the ratio of the Value added (constant Local Currency Unit) of Micronesia in 1996 to that in 2001?
Ensure brevity in your answer.  1. What is the ratio of the Value added (constant Local Currency Unit) of Cambodia in 1996 to that in 2002?
Ensure brevity in your answer.  0.88. What is the ratio of the Value added (constant Local Currency Unit) of Indonesia in 1996 to that in 2002?
Your answer should be very brief. 0.9. What is the ratio of the Value added (constant Local Currency Unit) in Micronesia in 1996 to that in 2002?
Your answer should be compact. 0.98. What is the ratio of the Value added (constant Local Currency Unit) of Cambodia in 1997 to that in 1998?
Your answer should be compact. 0.95. What is the ratio of the Value added (constant Local Currency Unit) in Indonesia in 1997 to that in 1998?
Offer a very short reply. 1.01. What is the ratio of the Value added (constant Local Currency Unit) in Micronesia in 1997 to that in 1998?
Offer a terse response. 0.87. What is the ratio of the Value added (constant Local Currency Unit) of Indonesia in 1997 to that in 1999?
Provide a short and direct response. 0.99. What is the ratio of the Value added (constant Local Currency Unit) of Micronesia in 1997 to that in 1999?
Provide a succinct answer. 0.94. What is the ratio of the Value added (constant Local Currency Unit) of Cambodia in 1997 to that in 2000?
Offer a very short reply. 0.93. What is the ratio of the Value added (constant Local Currency Unit) in Indonesia in 1997 to that in 2000?
Give a very brief answer. 0.97. What is the ratio of the Value added (constant Local Currency Unit) of Micronesia in 1997 to that in 2000?
Provide a short and direct response. 0.88. What is the ratio of the Value added (constant Local Currency Unit) of Cambodia in 1997 to that in 2001?
Ensure brevity in your answer.  0.9. What is the ratio of the Value added (constant Local Currency Unit) of Indonesia in 1997 to that in 2001?
Your answer should be compact. 0.94. What is the ratio of the Value added (constant Local Currency Unit) in Micronesia in 1997 to that in 2001?
Ensure brevity in your answer.  0.92. What is the ratio of the Value added (constant Local Currency Unit) in Cambodia in 1997 to that in 2002?
Provide a succinct answer. 0.92. What is the ratio of the Value added (constant Local Currency Unit) in Indonesia in 1997 to that in 2002?
Make the answer very short. 0.91. What is the ratio of the Value added (constant Local Currency Unit) of Micronesia in 1997 to that in 2002?
Your response must be concise. 0.9. What is the ratio of the Value added (constant Local Currency Unit) of Cambodia in 1998 to that in 1999?
Make the answer very short. 0.98. What is the ratio of the Value added (constant Local Currency Unit) of Indonesia in 1998 to that in 1999?
Make the answer very short. 0.98. What is the ratio of the Value added (constant Local Currency Unit) in Micronesia in 1998 to that in 1999?
Your response must be concise. 1.08. What is the ratio of the Value added (constant Local Currency Unit) in Cambodia in 1998 to that in 2000?
Your response must be concise. 0.98. What is the ratio of the Value added (constant Local Currency Unit) of Indonesia in 1998 to that in 2000?
Your answer should be very brief. 0.96. What is the ratio of the Value added (constant Local Currency Unit) of Micronesia in 1998 to that in 2000?
Give a very brief answer. 1.01. What is the ratio of the Value added (constant Local Currency Unit) in Cambodia in 1998 to that in 2001?
Keep it short and to the point. 0.95. What is the ratio of the Value added (constant Local Currency Unit) in Indonesia in 1998 to that in 2001?
Provide a short and direct response. 0.93. What is the ratio of the Value added (constant Local Currency Unit) of Micronesia in 1998 to that in 2001?
Your answer should be very brief. 1.05. What is the ratio of the Value added (constant Local Currency Unit) in Cambodia in 1998 to that in 2002?
Make the answer very short. 0.97. What is the ratio of the Value added (constant Local Currency Unit) in Indonesia in 1998 to that in 2002?
Provide a succinct answer. 0.9. What is the ratio of the Value added (constant Local Currency Unit) of Micronesia in 1998 to that in 2002?
Keep it short and to the point. 1.03. What is the ratio of the Value added (constant Local Currency Unit) of Cambodia in 1999 to that in 2000?
Offer a very short reply. 1. What is the ratio of the Value added (constant Local Currency Unit) of Indonesia in 1999 to that in 2000?
Make the answer very short. 0.98. What is the ratio of the Value added (constant Local Currency Unit) of Micronesia in 1999 to that in 2000?
Provide a short and direct response. 0.94. What is the ratio of the Value added (constant Local Currency Unit) in Cambodia in 1999 to that in 2001?
Offer a terse response. 0.97. What is the ratio of the Value added (constant Local Currency Unit) of Indonesia in 1999 to that in 2001?
Provide a succinct answer. 0.95. What is the ratio of the Value added (constant Local Currency Unit) in Micronesia in 1999 to that in 2001?
Ensure brevity in your answer.  0.97. What is the ratio of the Value added (constant Local Currency Unit) in Indonesia in 1999 to that in 2002?
Make the answer very short. 0.92. What is the ratio of the Value added (constant Local Currency Unit) in Micronesia in 1999 to that in 2002?
Keep it short and to the point. 0.95. What is the ratio of the Value added (constant Local Currency Unit) in Cambodia in 2000 to that in 2001?
Ensure brevity in your answer.  0.97. What is the ratio of the Value added (constant Local Currency Unit) of Indonesia in 2000 to that in 2001?
Your response must be concise. 0.97. What is the ratio of the Value added (constant Local Currency Unit) in Micronesia in 2000 to that in 2001?
Your answer should be compact. 1.03. What is the ratio of the Value added (constant Local Currency Unit) of Cambodia in 2000 to that in 2002?
Offer a very short reply. 0.99. What is the ratio of the Value added (constant Local Currency Unit) of Indonesia in 2000 to that in 2002?
Give a very brief answer. 0.94. What is the ratio of the Value added (constant Local Currency Unit) of Micronesia in 2000 to that in 2002?
Your response must be concise. 1.01. What is the ratio of the Value added (constant Local Currency Unit) in Cambodia in 2001 to that in 2002?
Provide a short and direct response. 1.03. What is the ratio of the Value added (constant Local Currency Unit) of Indonesia in 2001 to that in 2002?
Provide a succinct answer. 0.97. What is the ratio of the Value added (constant Local Currency Unit) of Micronesia in 2001 to that in 2002?
Make the answer very short. 0.98. What is the difference between the highest and the second highest Value added (constant Local Currency Unit) of Cambodia?
Your answer should be compact. 1.30e+11. What is the difference between the highest and the second highest Value added (constant Local Currency Unit) of Indonesia?
Your response must be concise. 2.42e+13. What is the difference between the highest and the second highest Value added (constant Local Currency Unit) in Micronesia?
Ensure brevity in your answer.  5.61e+05. What is the difference between the highest and the lowest Value added (constant Local Currency Unit) of Cambodia?
Ensure brevity in your answer.  8.17e+11. What is the difference between the highest and the lowest Value added (constant Local Currency Unit) in Indonesia?
Make the answer very short. 9.08e+13. What is the difference between the highest and the lowest Value added (constant Local Currency Unit) in Micronesia?
Your answer should be very brief. 7.32e+06. 